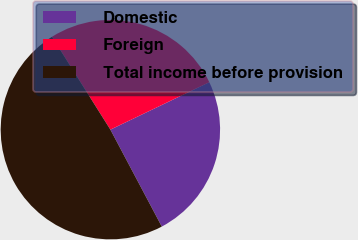<chart> <loc_0><loc_0><loc_500><loc_500><pie_chart><fcel>Domestic<fcel>Foreign<fcel>Total income before provision<nl><fcel>24.36%<fcel>26.81%<fcel>48.83%<nl></chart> 